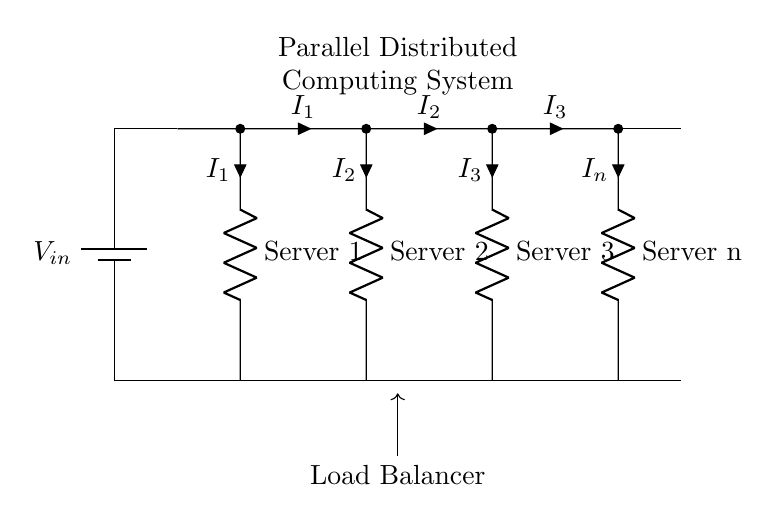What is the input voltage of the circuit? The input voltage, denoted as V_in in the diagram, is the voltage supplied by the battery. It is the potential difference at the start of the circuit before any load or branches.
Answer: V_in How many servers are represented in this circuit? Each branch of the parallel circuit represents a server, and there are four branches labeled as Server 1, Server 2, Server 3, and Server n. Thus, there are a total of four servers in this circuit.
Answer: 4 What is the significance of the Load Balancer in this circuit? The Load Balancer is labeled in the diagram, indicating its role in distributing the input current to each server connected in parallel. This ensures that each server can take on a portion of the total current, similar to how tasks are distributed in a distributed computing system.
Answer: Distributing tasks What is the current in Server 2? The current flowing through Server 2 is denoted as I_2 in the diagram, which represents the specific amount of current allocated to that server within the parallel circuit.
Answer: I_2 If Server 3 fails, how would the load change for the remaining servers? In a parallel circuit, if one branch (like Server 3) fails, the total current from the source is redistributed among the remaining operational servers (Server 1, Server 2, and Server n). Consequently, these servers will experience an increase in current, as the total current is the sum of the currents in the parallel branches.
Answer: Increases in remaining servers What happens to the total current if one additional server is added? If an additional server is added in parallel, the total current drawn from the input source will increase because the load is shared across more branches. This is characteristic of parallel configurations, as new paths allow for additional current flow in the circuit.
Answer: Total current increases What does the symbol "R" represent in this circuit? The "R" symbols in the diagram represent resistors, which in this context can be interpreted as individual servers handling different loads in the distributed system. Each resistor is representative of the electrical resistance associated with each server's operation.
Answer: Resistors 